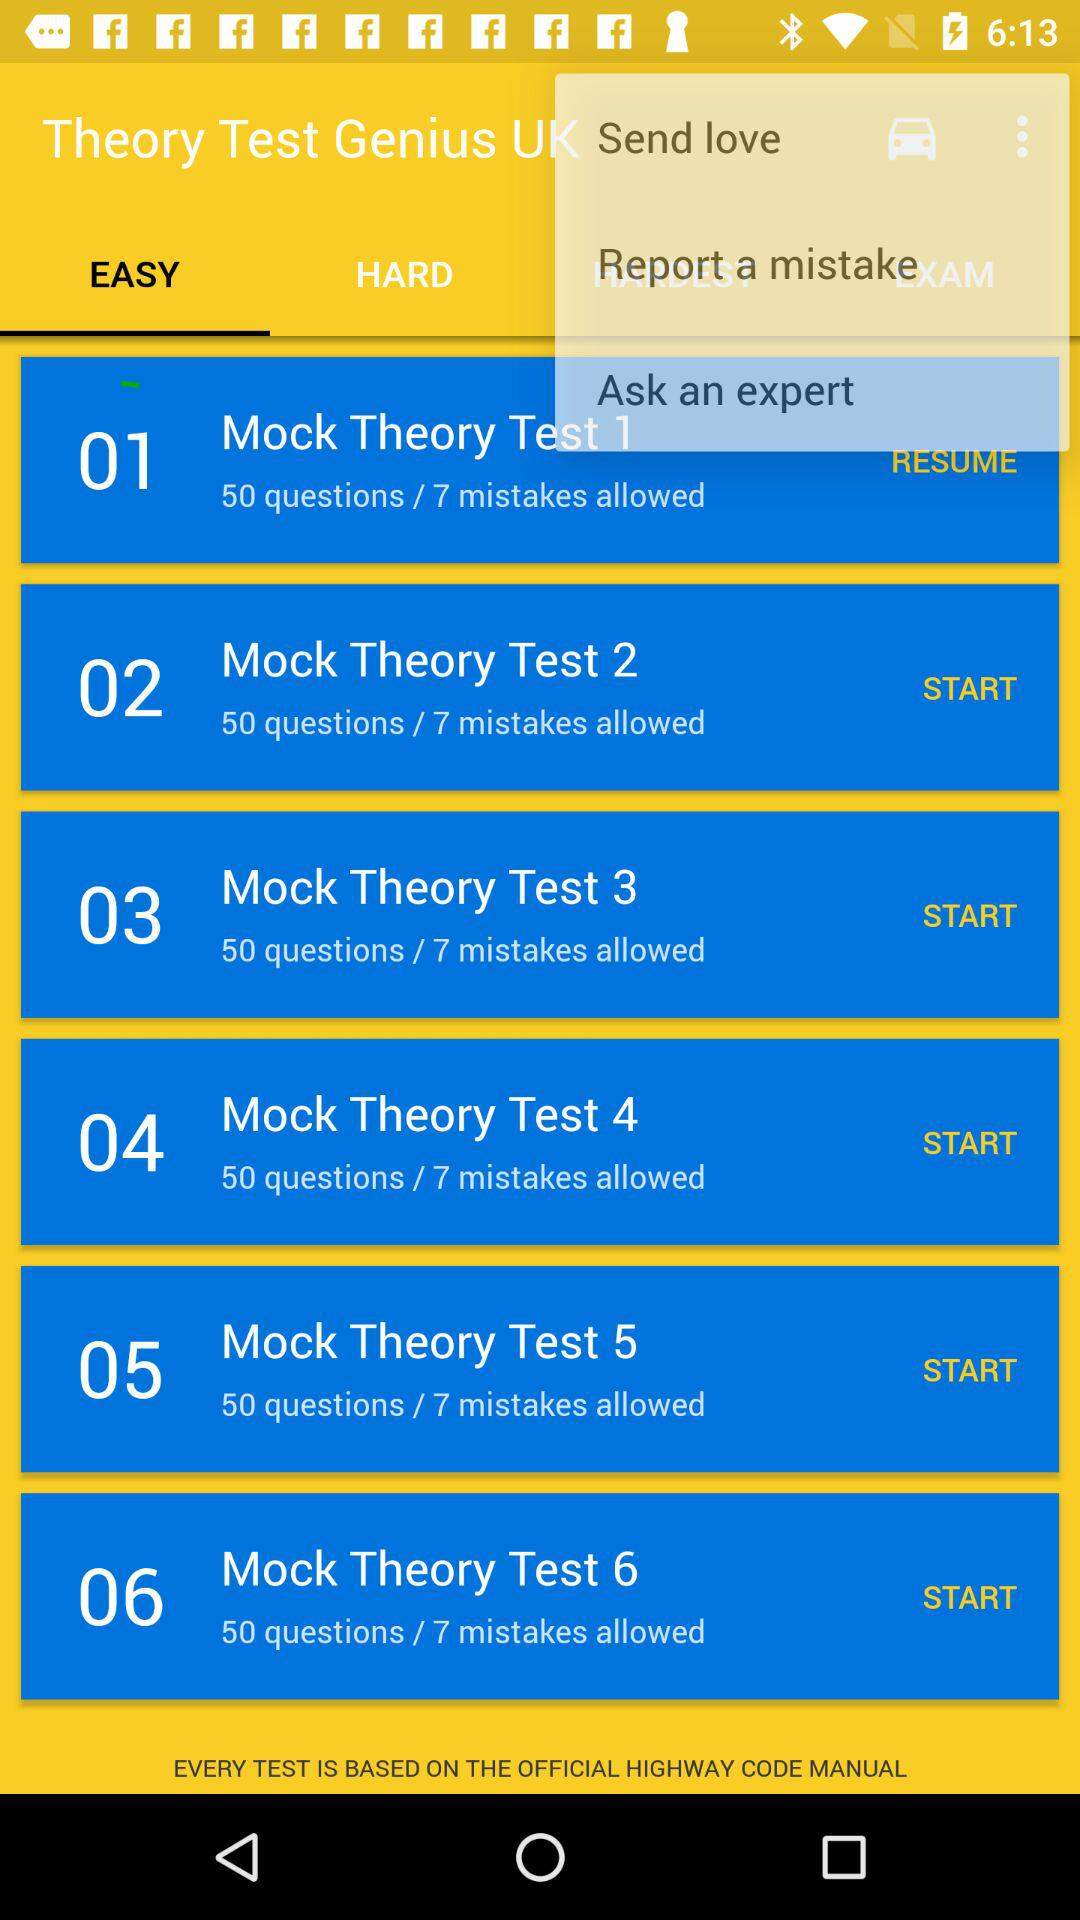How long does "Mock Theory Test 3" take to complete?
When the provided information is insufficient, respond with <no answer>. <no answer> 